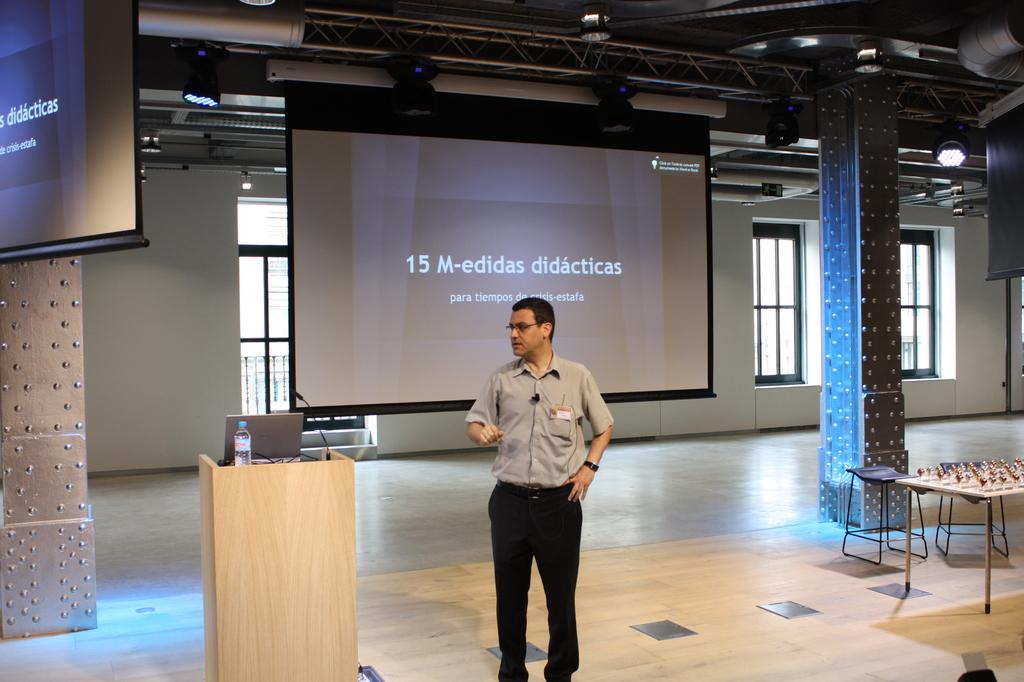What is the title of this presentation?
Provide a succinct answer. 15 m-edidas didacticas. Is there a number on the screen greater than 10?
Your answer should be very brief. Yes. 